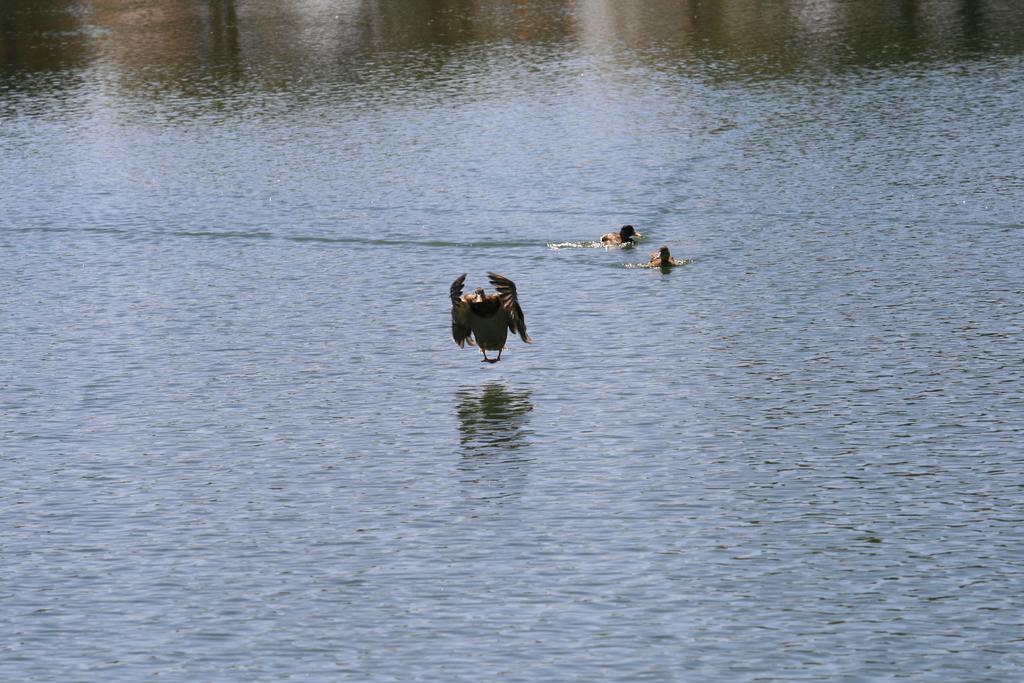What is the primary element in the image? There is water in the image. What animals can be seen in the image? There are birds in the image. What can be seen in the background of the image? There is a reflection of trees in the background of the image. What type of impulse can be seen affecting the birds in the image? There is no indication of any impulse affecting the birds in the image. Is there a bike visible in the image? No, there is no bike present in the image. 